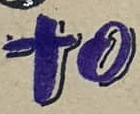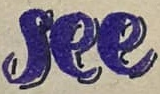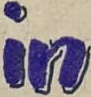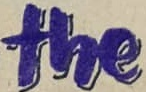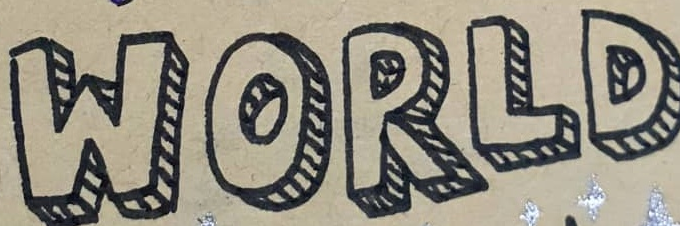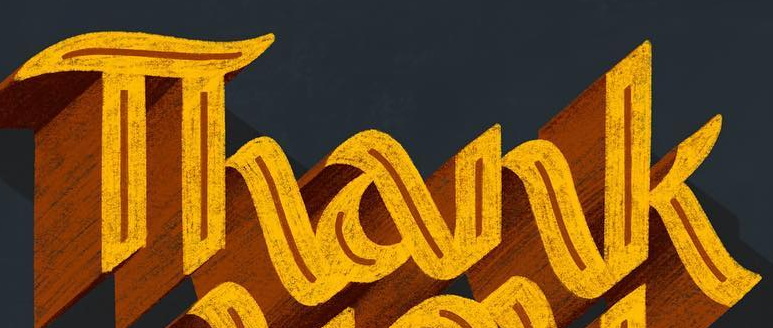Read the text from these images in sequence, separated by a semicolon. to; see; in; the; WORLD; Thank 